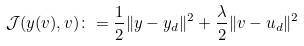<formula> <loc_0><loc_0><loc_500><loc_500>\mathcal { J } ( y ( v ) , v ) \colon = \frac { 1 } { 2 } \| y - y _ { d } \| ^ { 2 } + \frac { \lambda } { 2 } \| v - u _ { d } \| ^ { 2 }</formula> 